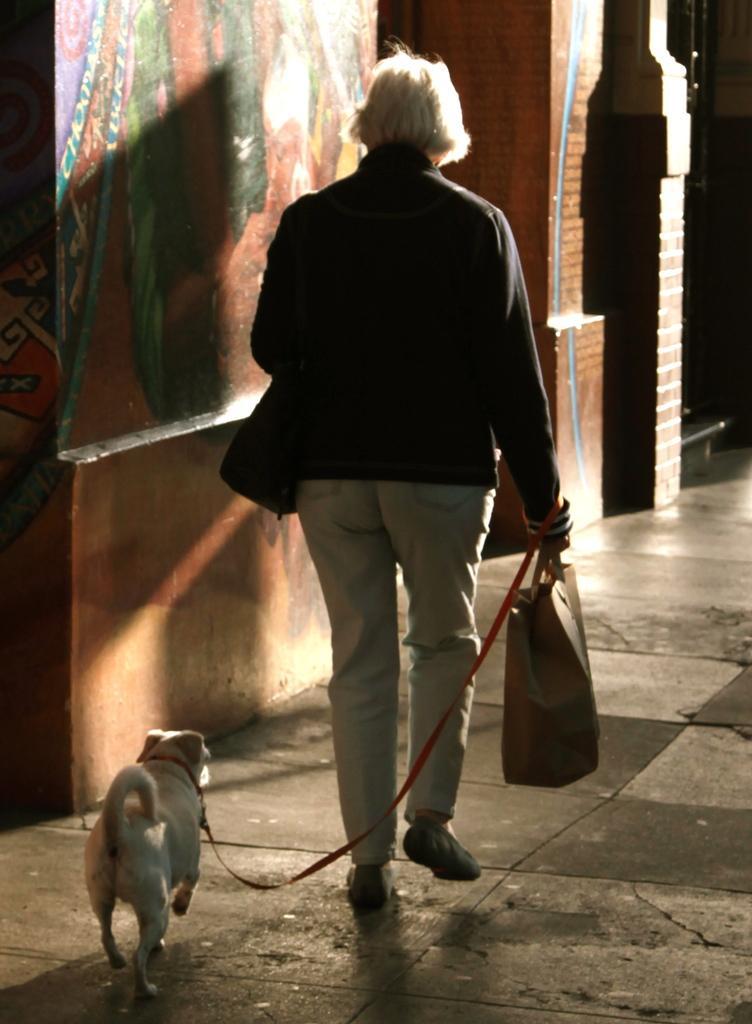How would you summarize this image in a sentence or two? He is walking like slowly. He's wearing a bag and dog thread. We can see in the background there is a red wall brick and road. 